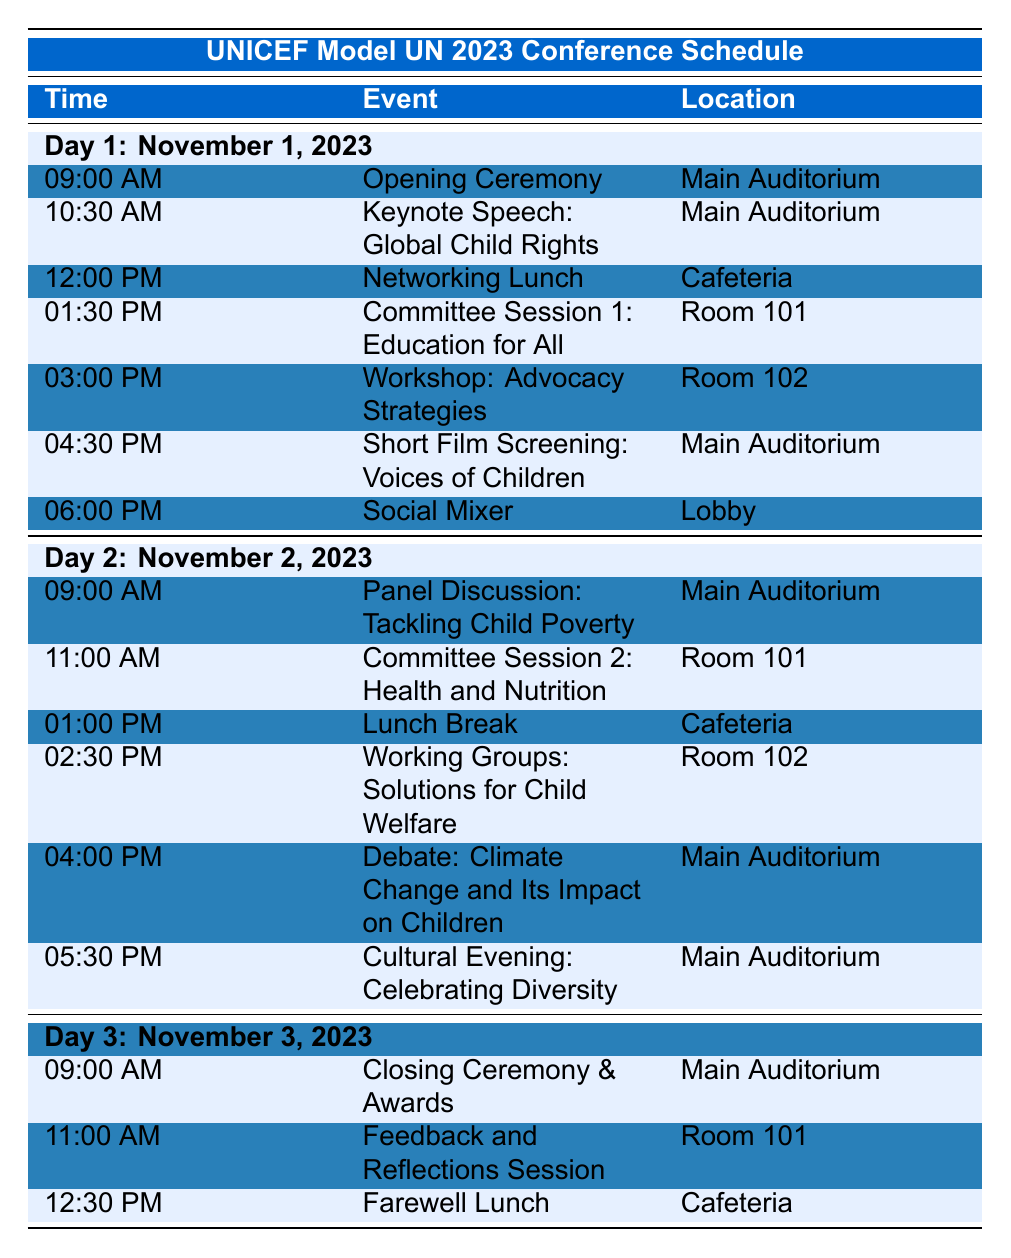What is the first event scheduled on Day 1? By checking the table for Day 1, the first event listed is the "Opening Ceremony" at 09:00 AM.
Answer: Opening Ceremony How many events are there in total on Day 2? There are six events listed under Day 2. This includes the Panel Discussion, Committee Session, Lunch Break, Working Groups, Debate, and Cultural Evening.
Answer: 6 What time is the Networking Lunch scheduled? The table indicates that the Networking Lunch is scheduled at 12:00 PM on Day 1.
Answer: 12:00 PM Is there a session related to health on Day 2? Yes, the table shows a "Committee Session 2: Health and Nutrition" scheduled at 11:00 AM on Day 2.
Answer: Yes What event takes place in the Main Auditorium right before the lunch break on Day 2? The event listed just before the lunch break at 01:00 PM is "Working Groups: Solutions for Child Welfare" at 02:30 PM. The event before this at 04:00 PM is "Debate: Climate Change and Its Impact on Children."
Answer: Debate: Climate Change and Its Impact on Children On which day is the Closing Ceremony scheduled? The Closing Ceremony is scheduled for Day 3, specifically at 09:00 AM.
Answer: Day 3 What is the duration of the break between the end of the opening ceremony and the next event on Day 1? The Opening Ceremony ends and the next event, "Keynote Speech: Global Child Rights," starts at 10:30 AM. The break is from 09:00 AM to 10:30 AM, which is 1 hour and 30 minutes.
Answer: 1 hour and 30 minutes Which day has the most events? Both Day 1 and Day 2 have 6 events listed, while Day 3 has only 3 events. So, Day 1 and Day 2 have the most events.
Answer: Day 1 and Day 2 What event takes place last on Day 3? The last event on Day 3 is "Farewell Lunch" scheduled at 12:30 PM.
Answer: Farewell Lunch How many events are scheduled before the lunch break on Day 1? There are 4 events listed before the Networking Lunch at 12:00 PM on Day 1: Opening Ceremony, Keynote Speech, Committee Session 1, and Workshop.
Answer: 4 